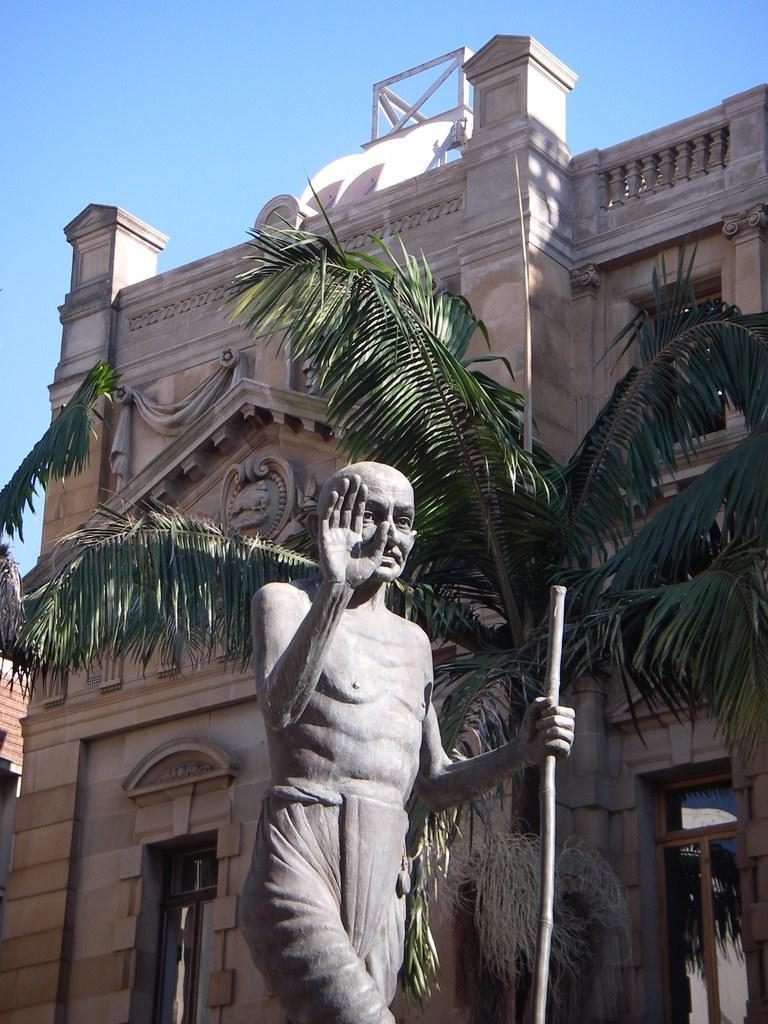Please provide a concise description of this image. In this image I can see at the bottom there is the statue. In the middle there is a tree and a building. At the top it is the sky. 